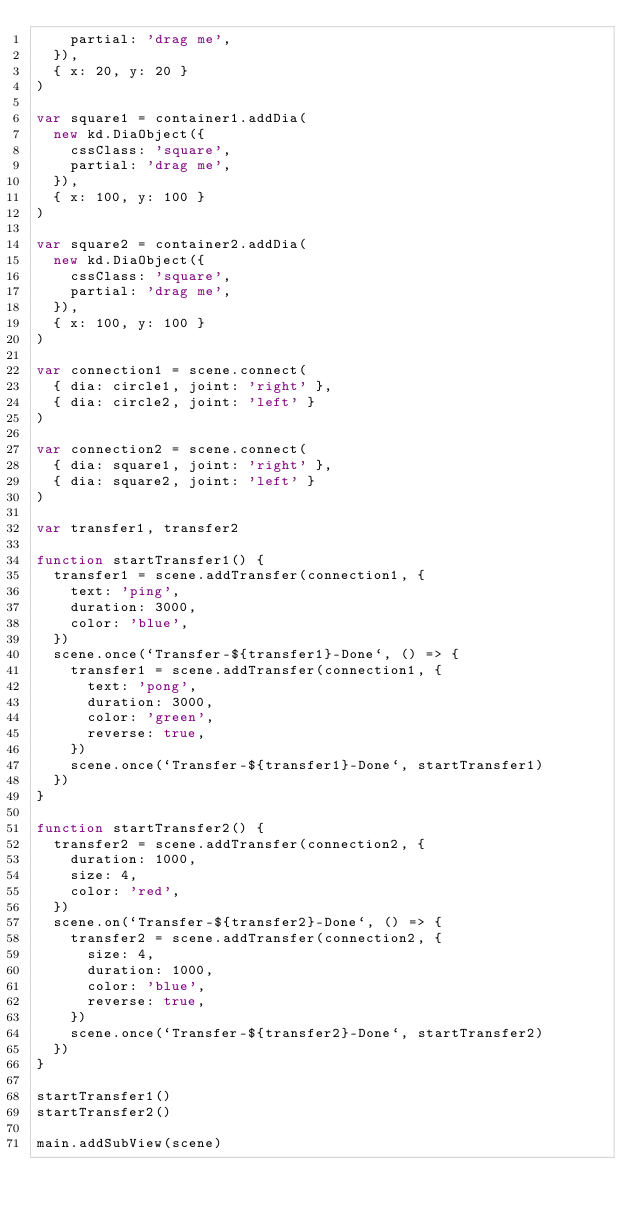Convert code to text. <code><loc_0><loc_0><loc_500><loc_500><_JavaScript_>    partial: 'drag me',
  }),
  { x: 20, y: 20 }
)

var square1 = container1.addDia(
  new kd.DiaObject({
    cssClass: 'square',
    partial: 'drag me',
  }),
  { x: 100, y: 100 }
)

var square2 = container2.addDia(
  new kd.DiaObject({
    cssClass: 'square',
    partial: 'drag me',
  }),
  { x: 100, y: 100 }
)

var connection1 = scene.connect(
  { dia: circle1, joint: 'right' },
  { dia: circle2, joint: 'left' }
)

var connection2 = scene.connect(
  { dia: square1, joint: 'right' },
  { dia: square2, joint: 'left' }
)

var transfer1, transfer2

function startTransfer1() {
  transfer1 = scene.addTransfer(connection1, {
    text: 'ping',
    duration: 3000,
    color: 'blue',
  })
  scene.once(`Transfer-${transfer1}-Done`, () => {
    transfer1 = scene.addTransfer(connection1, {
      text: 'pong',
      duration: 3000,
      color: 'green',
      reverse: true,
    })
    scene.once(`Transfer-${transfer1}-Done`, startTransfer1)
  })
}

function startTransfer2() {
  transfer2 = scene.addTransfer(connection2, {
    duration: 1000,
    size: 4,
    color: 'red',
  })
  scene.on(`Transfer-${transfer2}-Done`, () => {
    transfer2 = scene.addTransfer(connection2, {
      size: 4,
      duration: 1000,
      color: 'blue',
      reverse: true,
    })
    scene.once(`Transfer-${transfer2}-Done`, startTransfer2)
  })
}

startTransfer1()
startTransfer2()

main.addSubView(scene)
</code> 